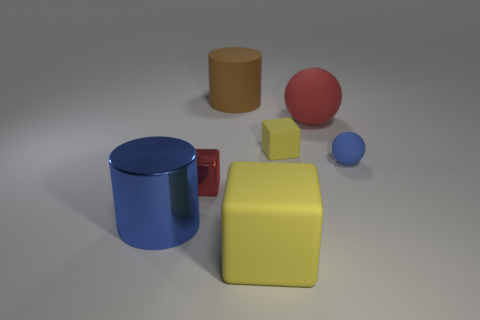Subtract all tiny rubber blocks. How many blocks are left? 2 Subtract all brown cylinders. How many cylinders are left? 1 Add 2 red objects. How many objects exist? 9 Subtract 1 cubes. How many cubes are left? 2 Subtract 1 red spheres. How many objects are left? 6 Subtract all blocks. How many objects are left? 4 Subtract all green blocks. Subtract all green spheres. How many blocks are left? 3 Subtract all gray cylinders. How many red balls are left? 1 Subtract all big yellow rubber blocks. Subtract all large metallic cylinders. How many objects are left? 5 Add 6 big blue cylinders. How many big blue cylinders are left? 7 